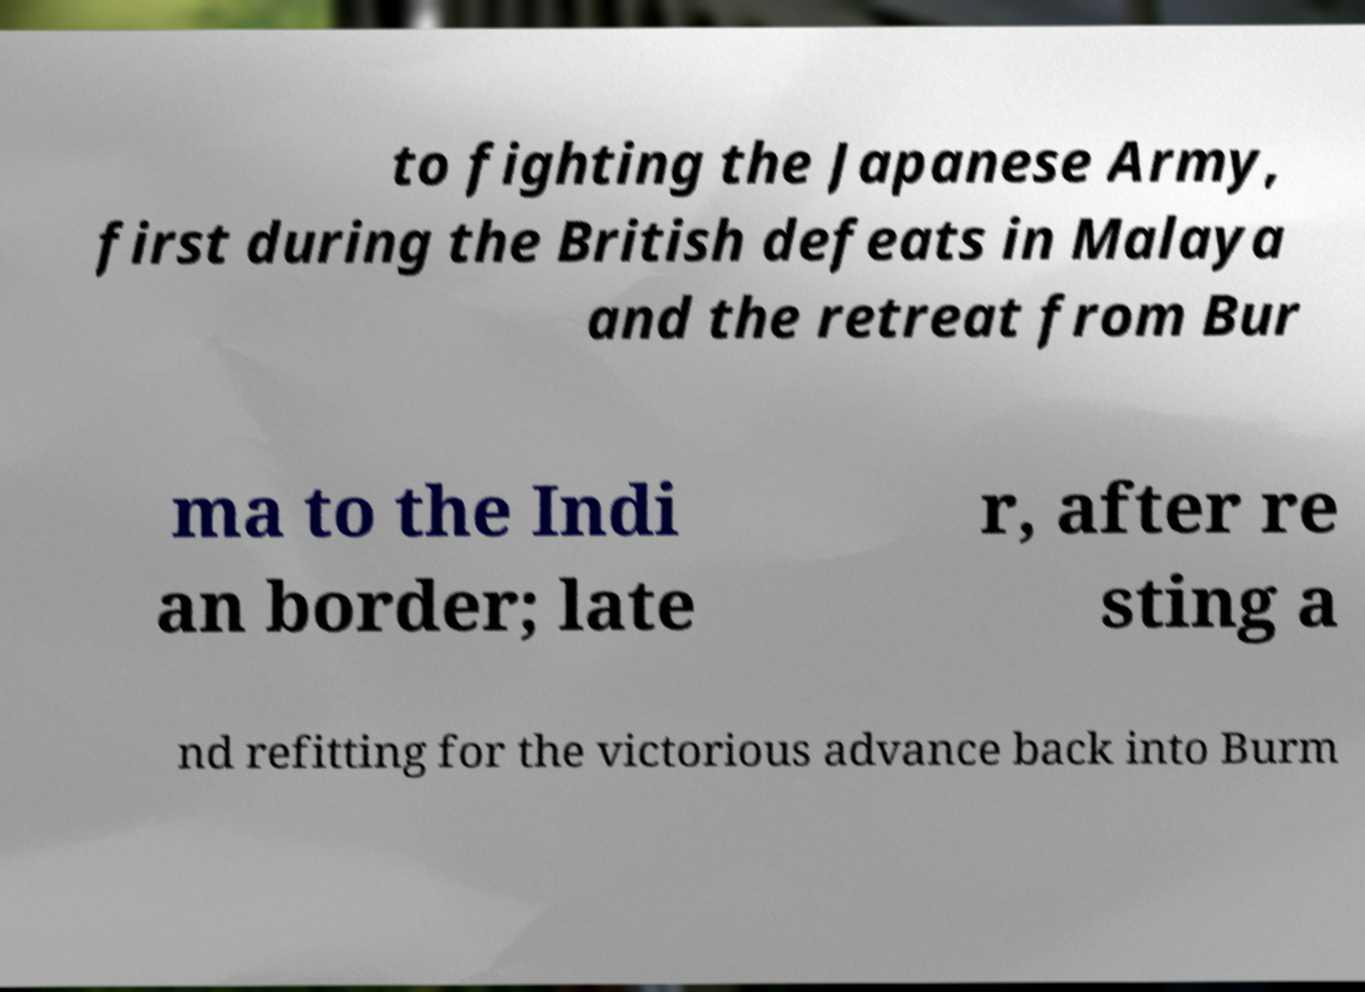Could you extract and type out the text from this image? to fighting the Japanese Army, first during the British defeats in Malaya and the retreat from Bur ma to the Indi an border; late r, after re sting a nd refitting for the victorious advance back into Burm 